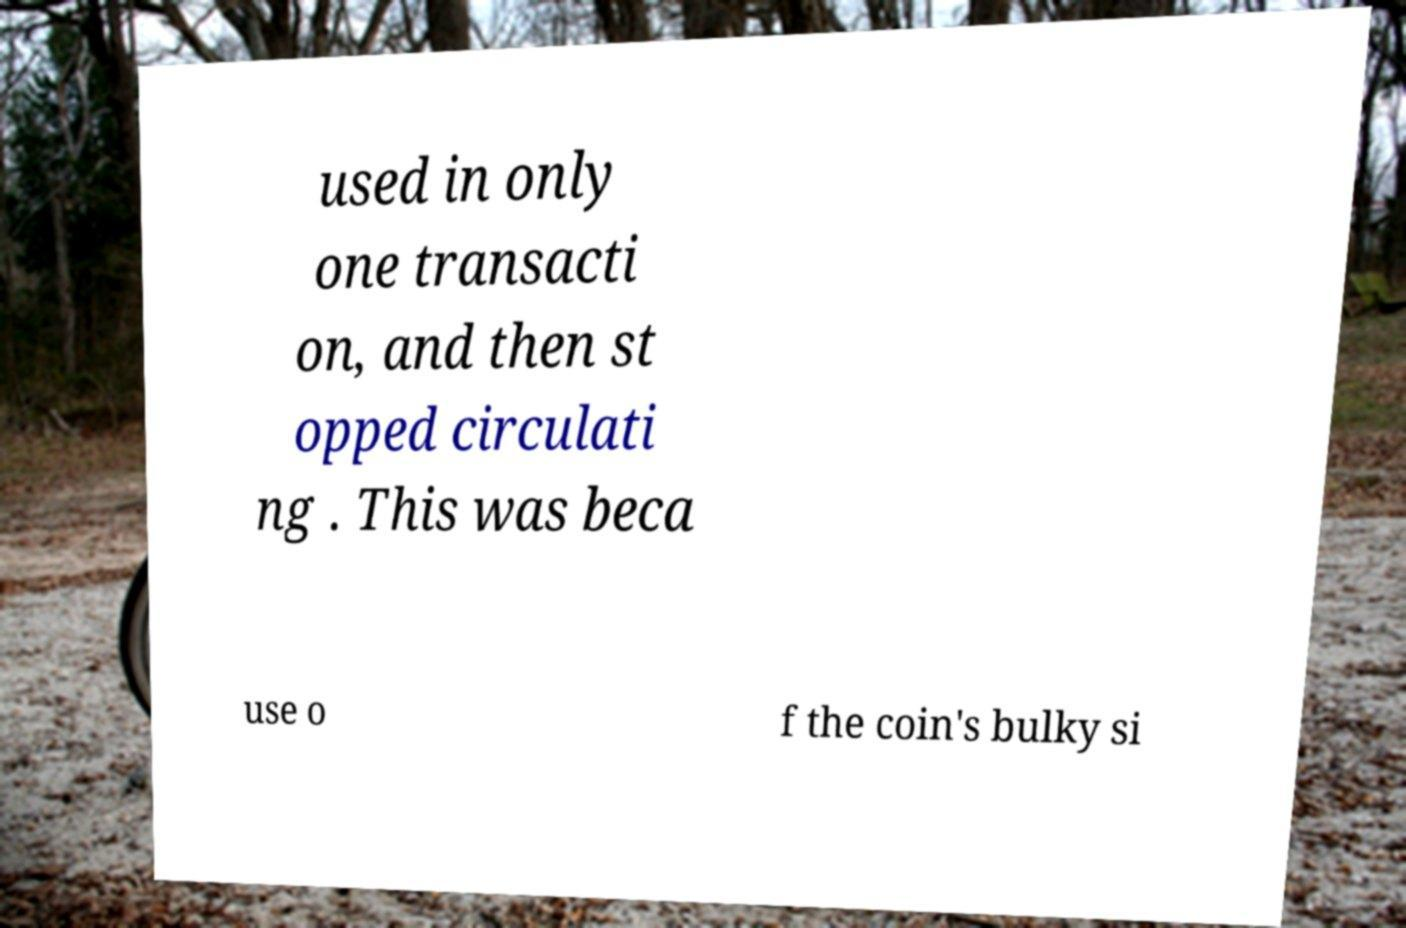Please identify and transcribe the text found in this image. used in only one transacti on, and then st opped circulati ng . This was beca use o f the coin's bulky si 